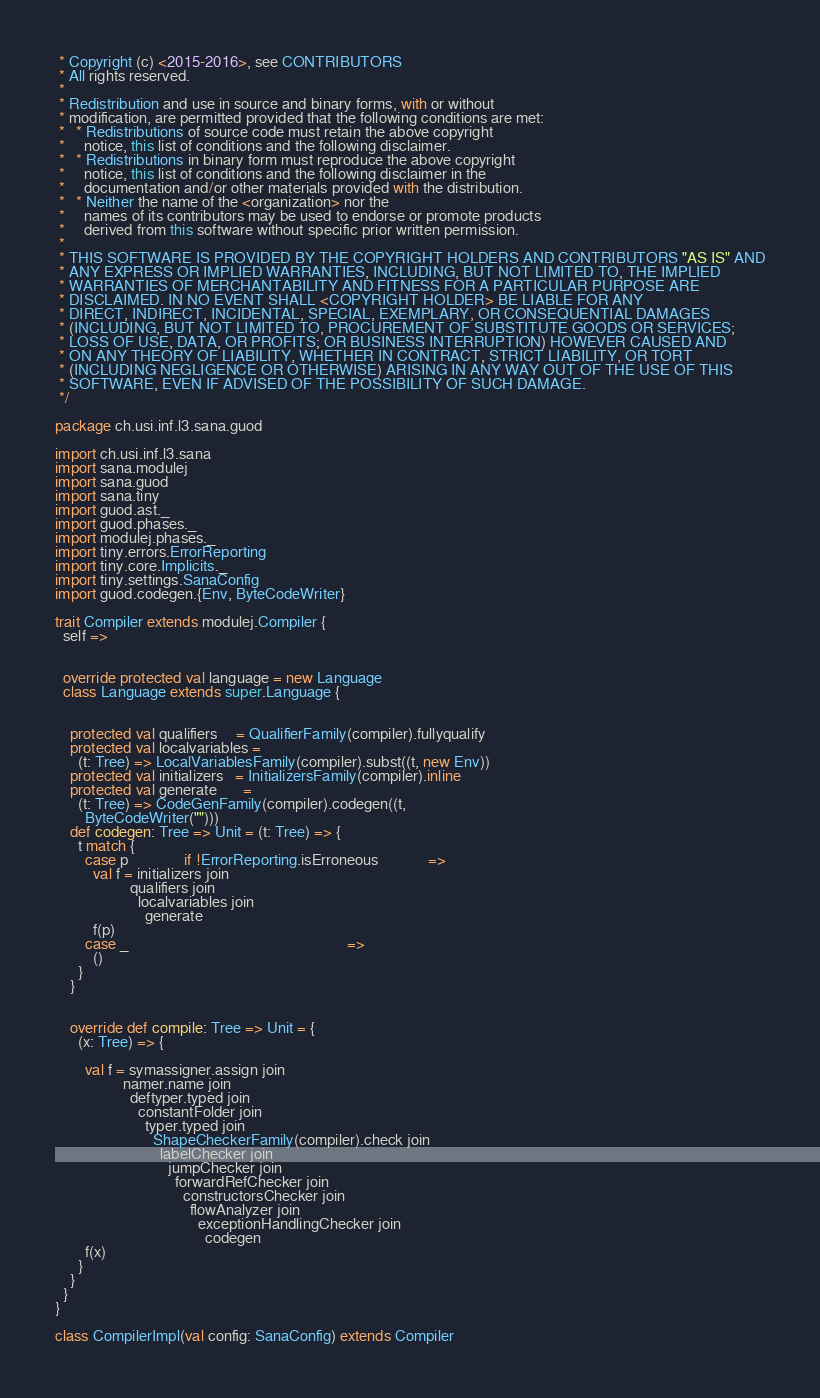<code> <loc_0><loc_0><loc_500><loc_500><_Scala_> * Copyright (c) <2015-2016>, see CONTRIBUTORS
 * All rights reserved.
 *
 * Redistribution and use in source and binary forms, with or without
 * modification, are permitted provided that the following conditions are met:
 *   * Redistributions of source code must retain the above copyright
 *     notice, this list of conditions and the following disclaimer.
 *   * Redistributions in binary form must reproduce the above copyright
 *     notice, this list of conditions and the following disclaimer in the
 *     documentation and/or other materials provided with the distribution.
 *   * Neither the name of the <organization> nor the
 *     names of its contributors may be used to endorse or promote products
 *     derived from this software without specific prior written permission.
 *
 * THIS SOFTWARE IS PROVIDED BY THE COPYRIGHT HOLDERS AND CONTRIBUTORS "AS IS" AND
 * ANY EXPRESS OR IMPLIED WARRANTIES, INCLUDING, BUT NOT LIMITED TO, THE IMPLIED
 * WARRANTIES OF MERCHANTABILITY AND FITNESS FOR A PARTICULAR PURPOSE ARE
 * DISCLAIMED. IN NO EVENT SHALL <COPYRIGHT HOLDER> BE LIABLE FOR ANY
 * DIRECT, INDIRECT, INCIDENTAL, SPECIAL, EXEMPLARY, OR CONSEQUENTIAL DAMAGES
 * (INCLUDING, BUT NOT LIMITED TO, PROCUREMENT OF SUBSTITUTE GOODS OR SERVICES;
 * LOSS OF USE, DATA, OR PROFITS; OR BUSINESS INTERRUPTION) HOWEVER CAUSED AND
 * ON ANY THEORY OF LIABILITY, WHETHER IN CONTRACT, STRICT LIABILITY, OR TORT
 * (INCLUDING NEGLIGENCE OR OTHERWISE) ARISING IN ANY WAY OUT OF THE USE OF THIS
 * SOFTWARE, EVEN IF ADVISED OF THE POSSIBILITY OF SUCH DAMAGE.
 */

package ch.usi.inf.l3.sana.guod

import ch.usi.inf.l3.sana
import sana.modulej
import sana.guod
import sana.tiny
import guod.ast._
import guod.phases._
import modulej.phases._
import tiny.errors.ErrorReporting
import tiny.core.Implicits._
import tiny.settings.SanaConfig
import guod.codegen.{Env, ByteCodeWriter}

trait Compiler extends modulej.Compiler {
  self =>


  override protected val language = new Language
  class Language extends super.Language {


    protected val qualifiers     = QualifierFamily(compiler).fullyqualify
    protected val localvariables =
      (t: Tree) => LocalVariablesFamily(compiler).subst((t, new Env))
    protected val initializers   = InitializersFamily(compiler).inline
    protected val generate       =
      (t: Tree) => CodeGenFamily(compiler).codegen((t,
        ByteCodeWriter("")))
    def codegen: Tree => Unit = (t: Tree) => {
      t match {
        case p               if !ErrorReporting.isErroneous             =>
          val f = initializers join
                    qualifiers join
                      localvariables join
                        generate
          f(p)
        case _                                                          =>
          ()
      }
    }


    override def compile: Tree => Unit = {
      (x: Tree) => {

        val f = symassigner.assign join
                  namer.name join
                    deftyper.typed join
                      constantFolder join
                        typer.typed join
                          ShapeCheckerFamily(compiler).check join
                            labelChecker join
                              jumpChecker join
                                forwardRefChecker join
                                  constructorsChecker join
                                    flowAnalyzer join
                                      exceptionHandlingChecker join
                                        codegen
        f(x)
      }
    }
  }
}

class CompilerImpl(val config: SanaConfig) extends Compiler
</code> 